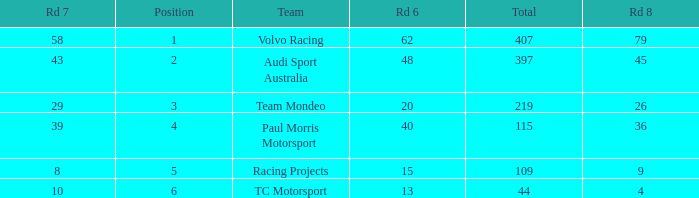What is the sum of values of Rd 7 with RD 6 less than 48 and Rd 8 less than 4 for TC Motorsport in a position greater than 1? None. 